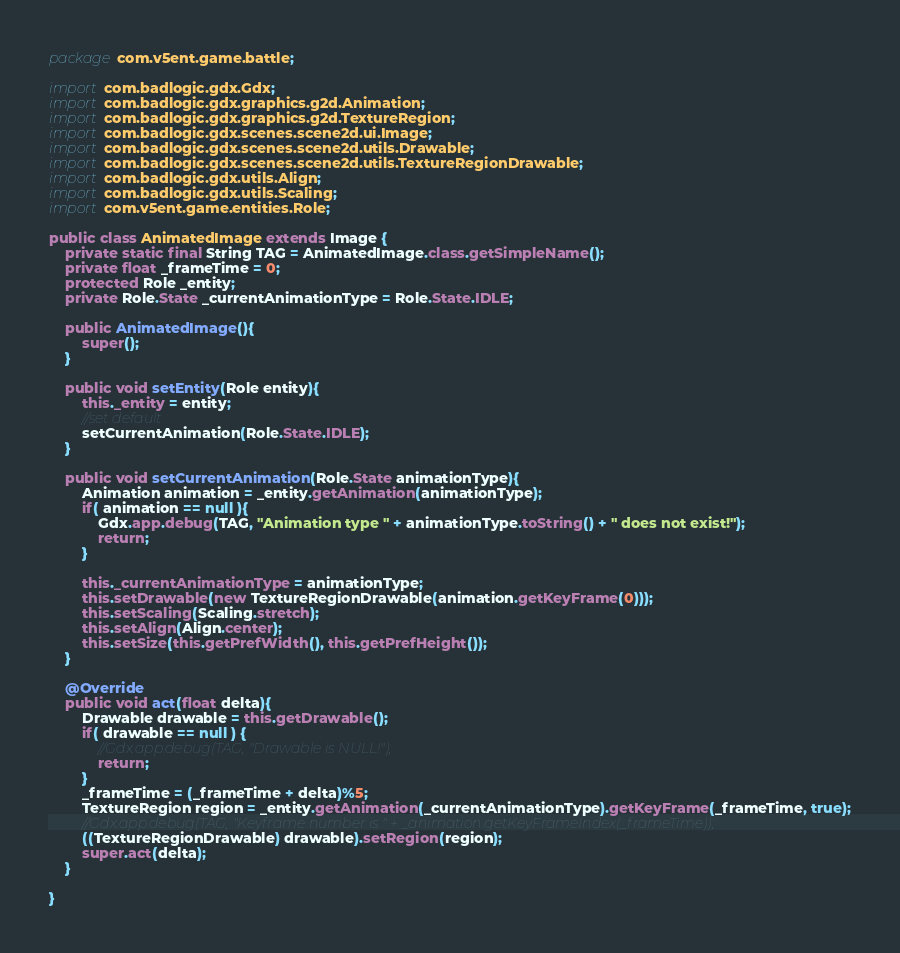<code> <loc_0><loc_0><loc_500><loc_500><_Java_>package com.v5ent.game.battle;

import com.badlogic.gdx.Gdx;
import com.badlogic.gdx.graphics.g2d.Animation;
import com.badlogic.gdx.graphics.g2d.TextureRegion;
import com.badlogic.gdx.scenes.scene2d.ui.Image;
import com.badlogic.gdx.scenes.scene2d.utils.Drawable;
import com.badlogic.gdx.scenes.scene2d.utils.TextureRegionDrawable;
import com.badlogic.gdx.utils.Align;
import com.badlogic.gdx.utils.Scaling;
import com.v5ent.game.entities.Role;

public class AnimatedImage extends Image {
    private static final String TAG = AnimatedImage.class.getSimpleName();
    private float _frameTime = 0;
    protected Role _entity;
    private Role.State _currentAnimationType = Role.State.IDLE;

    public AnimatedImage(){
        super();
    }

    public void setEntity(Role entity){
        this._entity = entity;
        //set default
        setCurrentAnimation(Role.State.IDLE);
    }

    public void setCurrentAnimation(Role.State animationType){
        Animation animation = _entity.getAnimation(animationType);
        if( animation == null ){
            Gdx.app.debug(TAG, "Animation type " + animationType.toString() + " does not exist!");
            return;
        }

        this._currentAnimationType = animationType;
        this.setDrawable(new TextureRegionDrawable(animation.getKeyFrame(0)));
        this.setScaling(Scaling.stretch);
        this.setAlign(Align.center);
        this.setSize(this.getPrefWidth(), this.getPrefHeight());
    }

    @Override
    public void act(float delta){
        Drawable drawable = this.getDrawable();
        if( drawable == null ) {
            //Gdx.app.debug(TAG, "Drawable is NULL!");
            return;
        }
        _frameTime = (_frameTime + delta)%5;
        TextureRegion region = _entity.getAnimation(_currentAnimationType).getKeyFrame(_frameTime, true);
        //Gdx.app.debug(TAG, "Keyframe number is " + _animation.getKeyFrameIndex(_frameTime));
        ((TextureRegionDrawable) drawable).setRegion(region);
        super.act(delta);
    }

}
</code> 